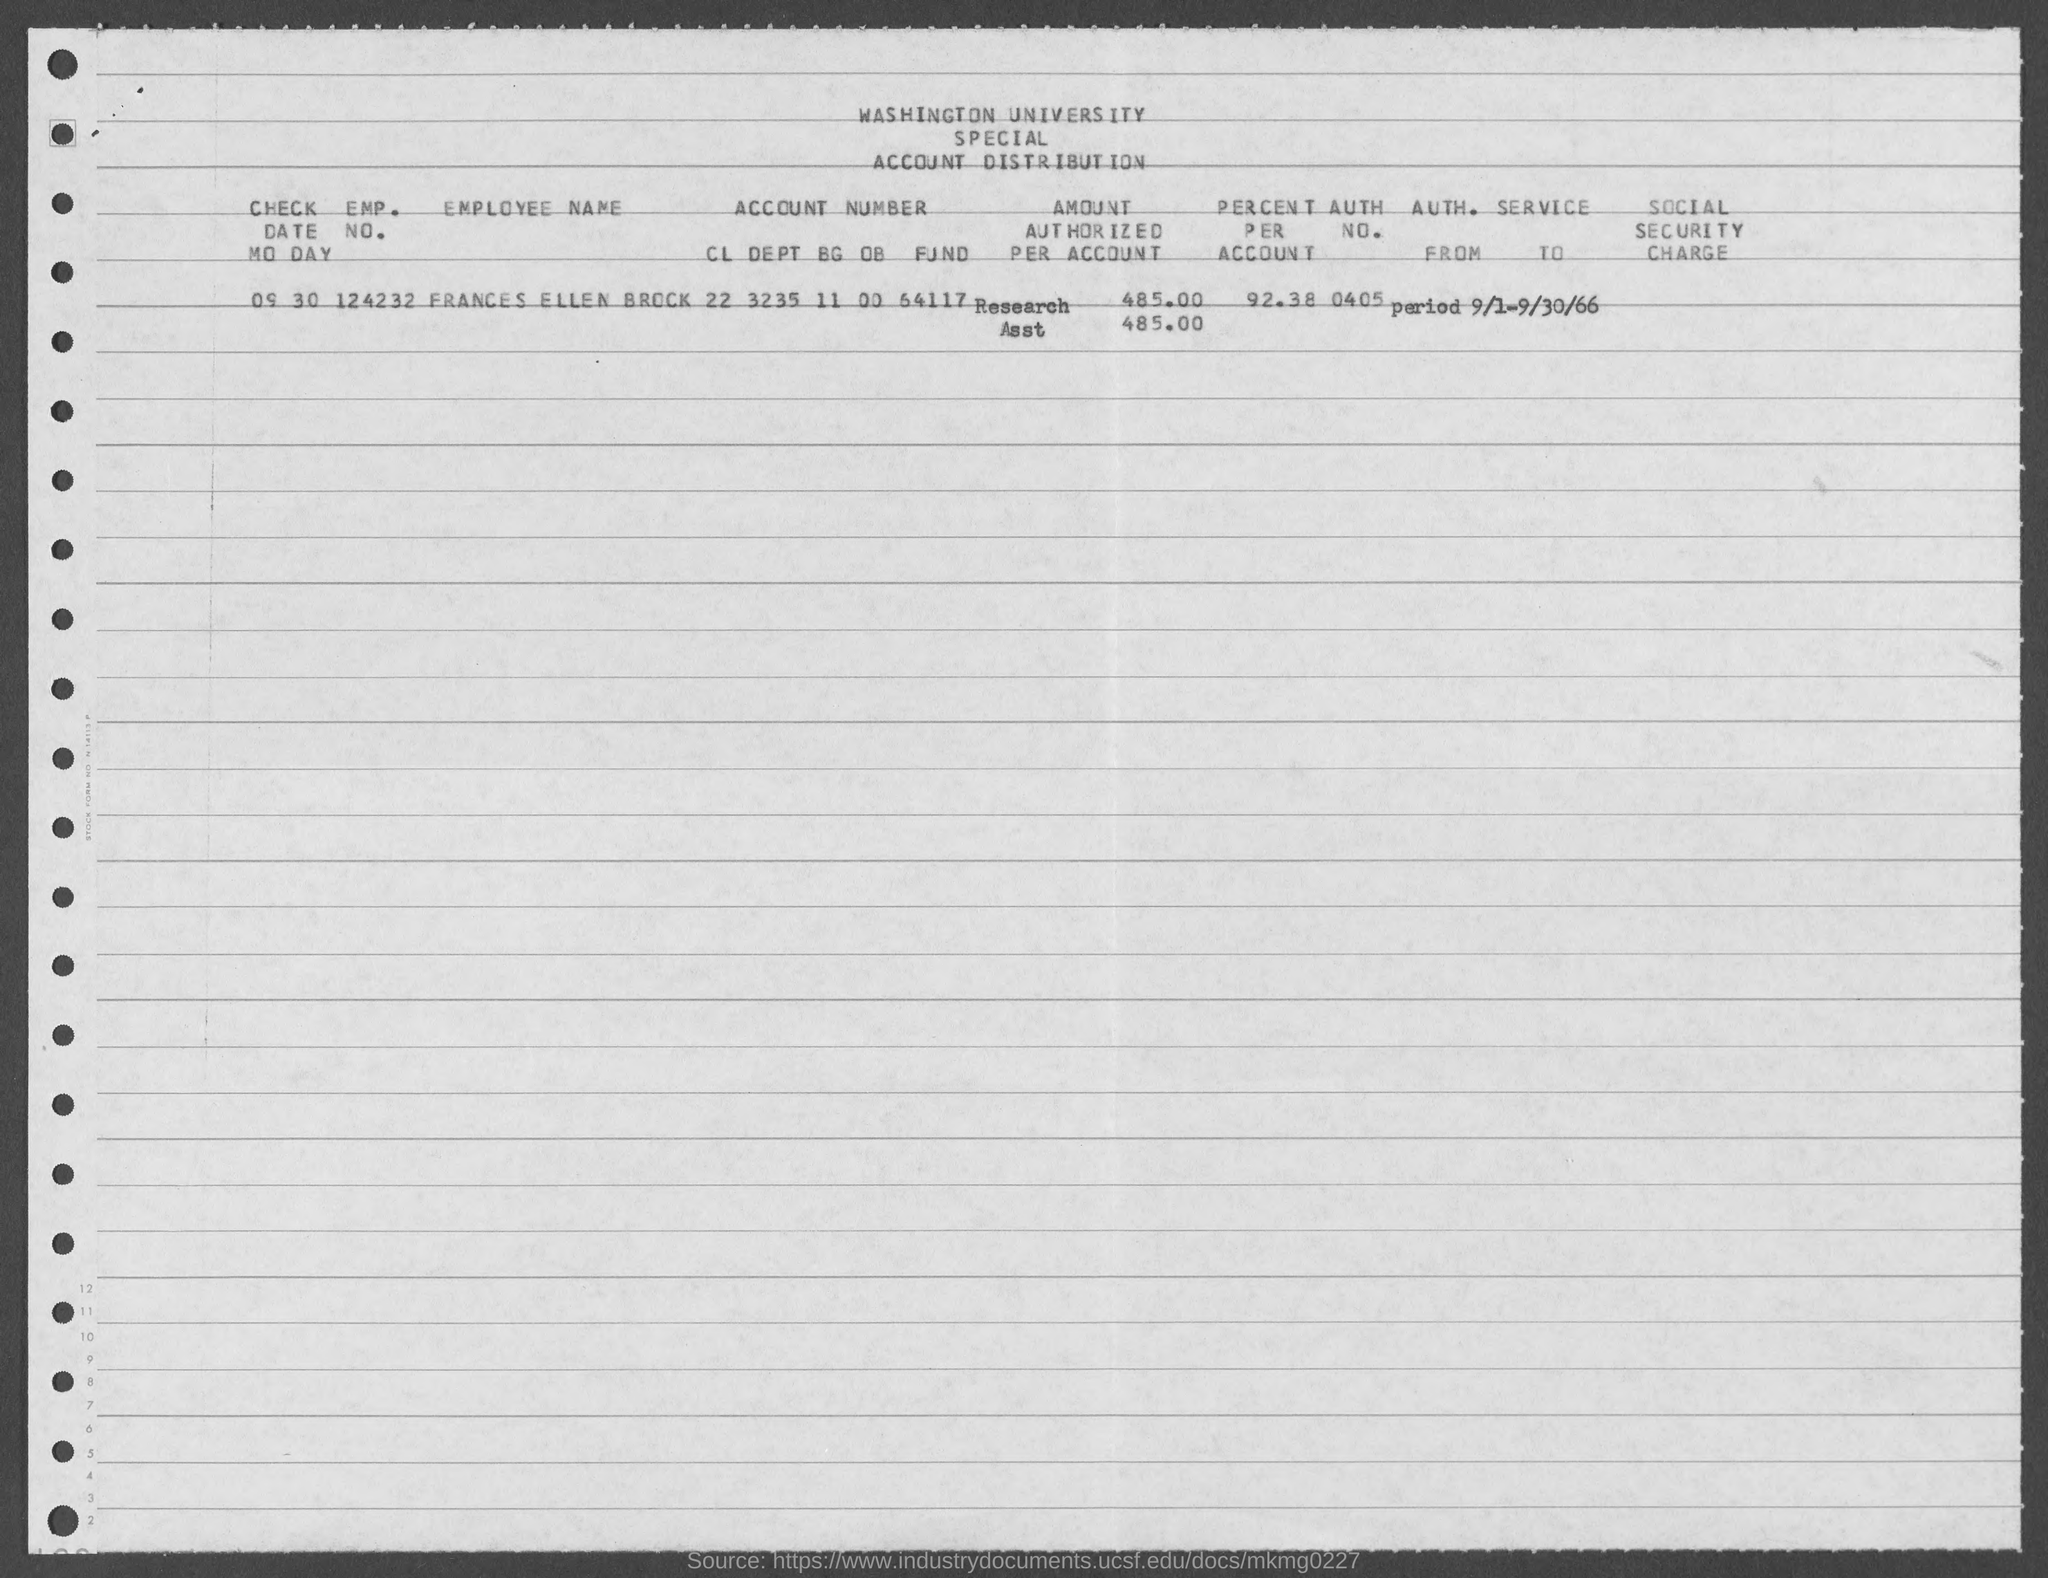Draw attention to some important aspects in this diagram. The employment number of Frances Ellen Brock is 124232. Frances Ellen Brock's account has a percentage of 92.38%. The employee's name is Frances Ellen Brock. The authorization number of Frances Ellen Brock is 0405. 